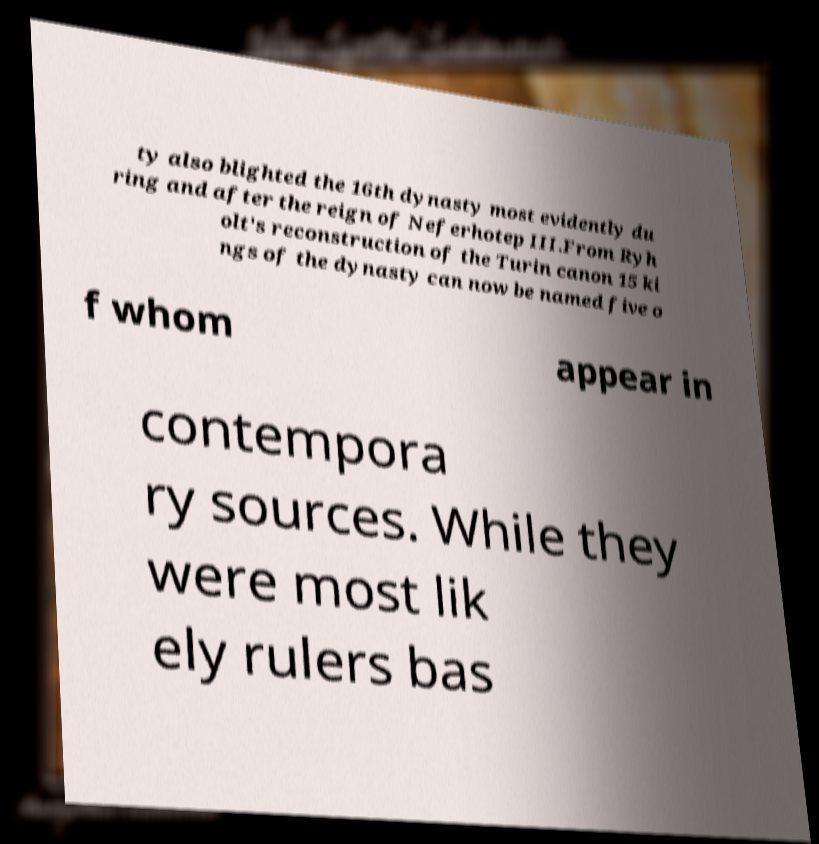Could you assist in decoding the text presented in this image and type it out clearly? ty also blighted the 16th dynasty most evidently du ring and after the reign of Neferhotep III.From Ryh olt's reconstruction of the Turin canon 15 ki ngs of the dynasty can now be named five o f whom appear in contempora ry sources. While they were most lik ely rulers bas 